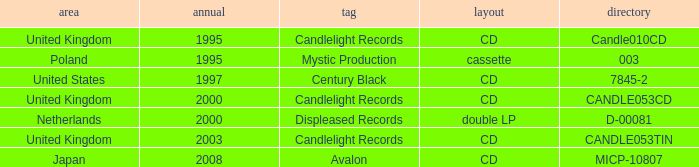What was the Candlelight Records Catalog of Candle053tin format? CD. 